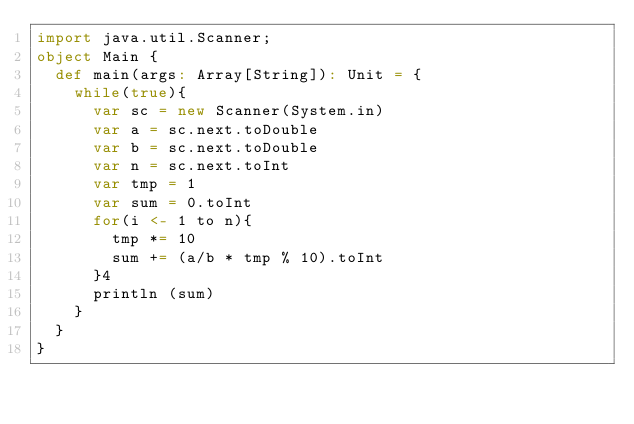<code> <loc_0><loc_0><loc_500><loc_500><_Scala_>import java.util.Scanner;
object Main {
  def main(args: Array[String]): Unit = {
    while(true){
      var sc = new Scanner(System.in)
      var a = sc.next.toDouble
      var b = sc.next.toDouble
      var n = sc.next.toInt
      var tmp = 1
      var sum = 0.toInt
      for(i <- 1 to n){
        tmp *= 10
        sum += (a/b * tmp % 10).toInt
      }4
      println (sum)
    }
  }
}</code> 